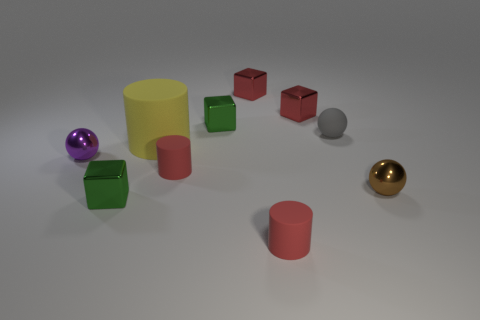What color is the small metal block that is on the left side of the big rubber thing that is on the right side of the metal ball on the left side of the gray object? green 